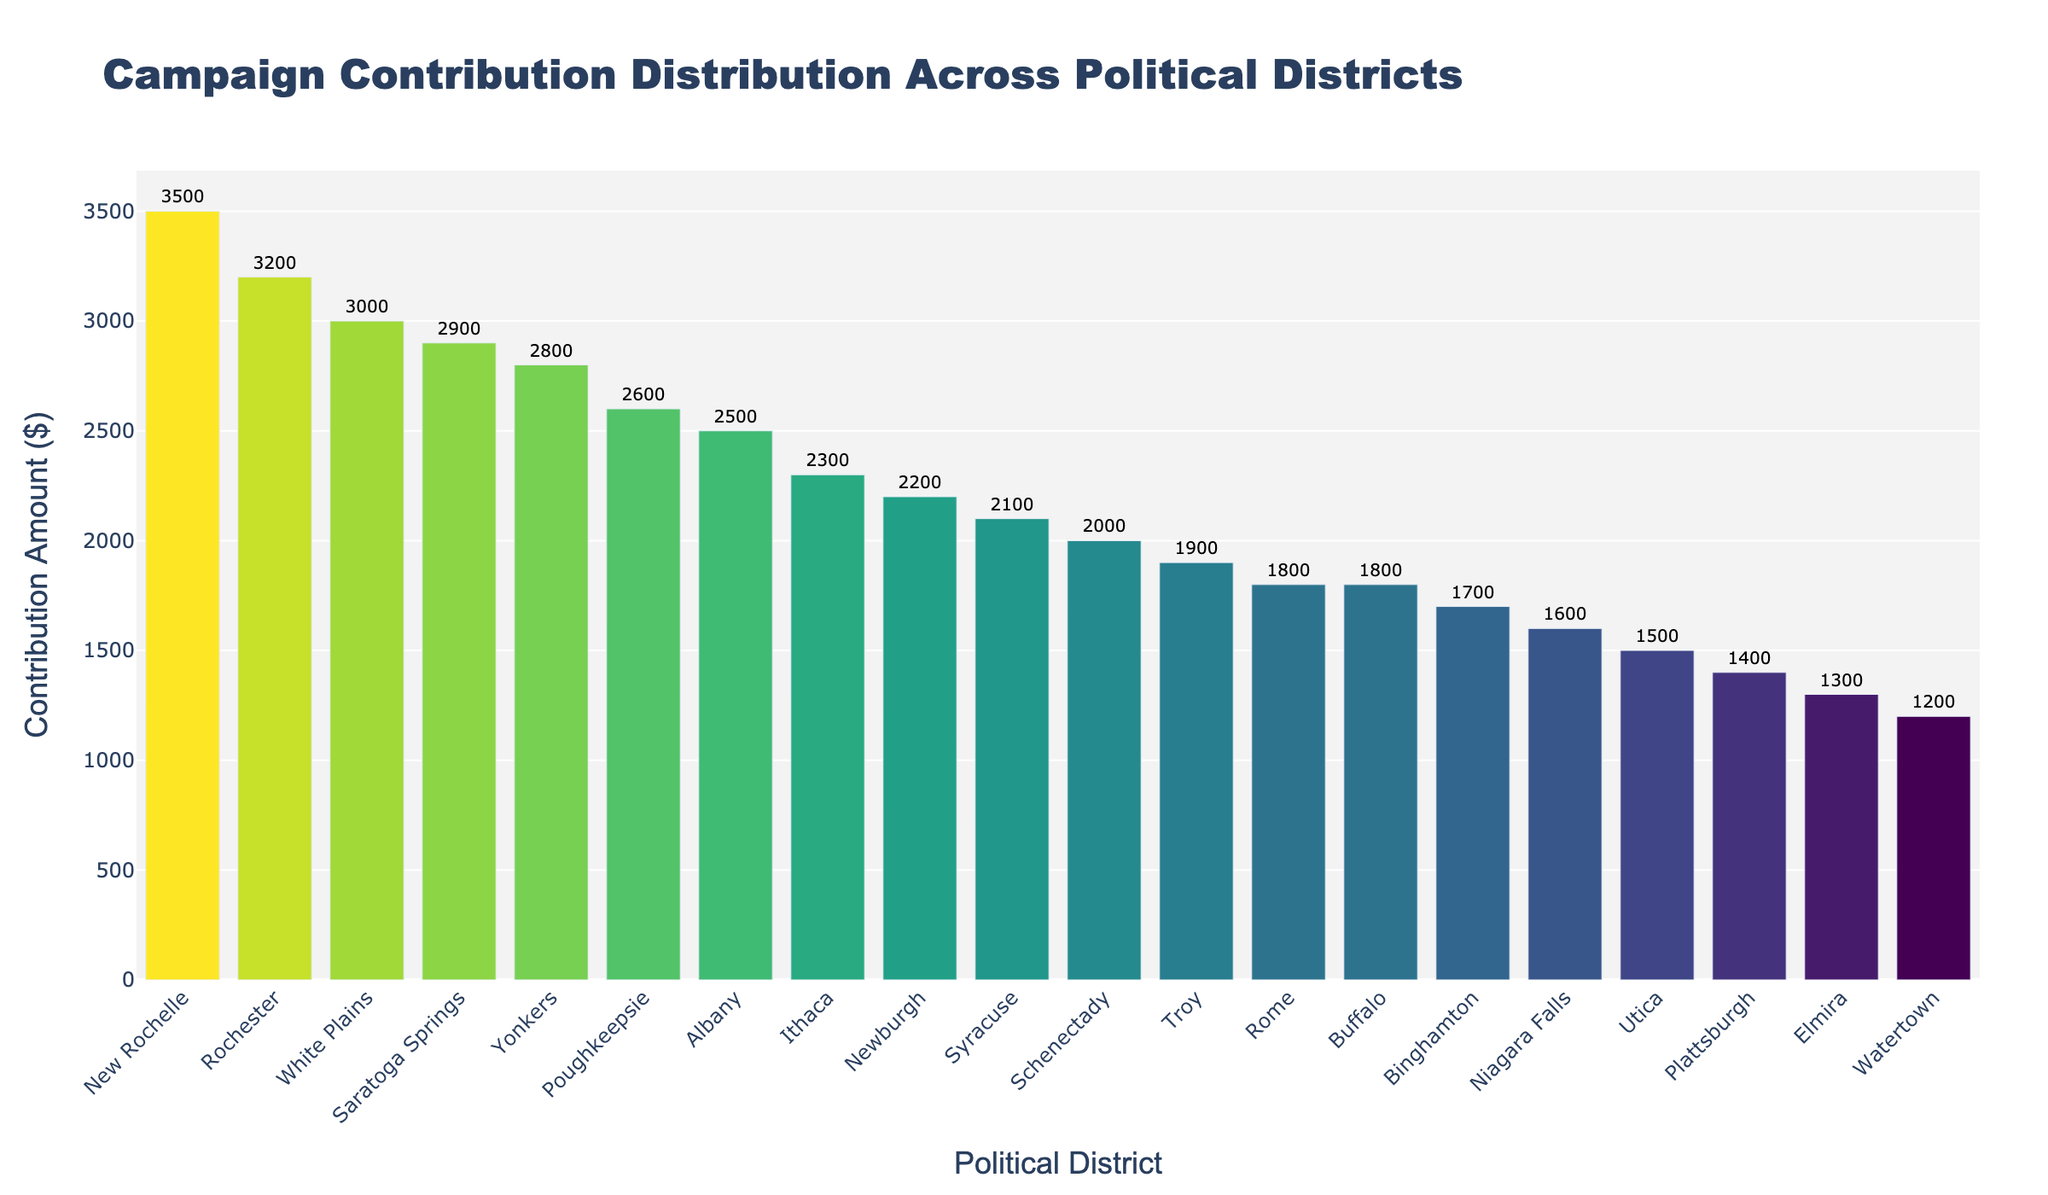What's the title of the plot? The title is prominently displayed at the top of the plot.
Answer: Campaign Contribution Distribution Across Political Districts Which district has the highest contribution amount? The district with the highest bar on the plot represents the highest contribution amount.
Answer: New Rochelle How many districts have a contribution amount greater than 2500? By inspecting the heights of the bars and their associated labels on the y-axis, we identify the districts with amounts greater than 2500.
Answer: 5 What is the contribution amount for Syracuse? Locate the bar labeled "Syracuse" and read the contribution value displayed.
Answer: 2100 What is the range of the contribution amounts? The range is calculated by subtracting the smallest contribution amount from the largest. The smallest contribution amount is for Watertown (1200), and the largest is for New Rochelle (3500).
Answer: 2300 Which district has a contribution amount closest to the median value? First, sort the contributions to find the median value, which is the middle number in an ordered list. The list of contributions sorted in ascending order is 1200, 1300, 1400, 1500, 1600, 1700, 1800, 1800, 1900, 2000, 2100, 2200, 2300, 2500, 2600, 2800, 2900, 3000, 3200, 3500. The median value (middle value) is 2150. The closest contribution is for Syracuse (2100).
Answer: Syracuse Compare the contributions of Albany and Rome. Which is higher and by how much? Locate the bars for Albany and Rome. Albany has a contribution of 2500, and Rome has 1800. Subtract the smaller amount from the larger amount (2500 - 1800).
Answer: Albany is higher by 700 Which districts have a log contribution color closer to yellow? The bars with higher contribution amounts appear closer to yellow due to the Viridis color scale. Identify these by their lighter shades.
Answer: New Rochelle, Rochester, White Plains Are there more districts with contributions below 2000 or above 2000? Count the number of districts with contributions below and above 2000 by inspecting the bars. Below 2000: Albany, Buffalo, Utica, Binghamton, Schenectady, Niagara Falls, Troy, Plattsburgh, Elmira, Watertown, Rome (11 districts). Above 2000: New Rochelle, Rochester, White Plains, Yonkers, Saratoga Springs, Poughkeepsie, Ithaca, Albany, Syracuse, Newburgh (9 districts).
Answer: Below 2000 What is the average contribution amount for the top 5 districts? Sum contribution amounts of the top 5 districts (3500 + 3200 + 3000 + 2900 + 2800) and divide by 5. ((3500 + 3200 + 3000 + 2900 + 2800) / 5 = 15400 / 5).
Answer: 3080 